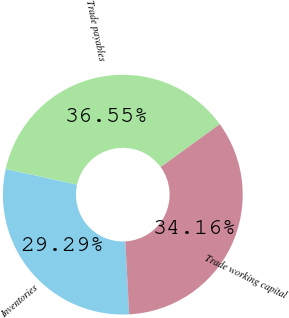<chart> <loc_0><loc_0><loc_500><loc_500><pie_chart><fcel>Inventories<fcel>Trade payables<fcel>Trade working capital<nl><fcel>29.29%<fcel>36.55%<fcel>34.16%<nl></chart> 